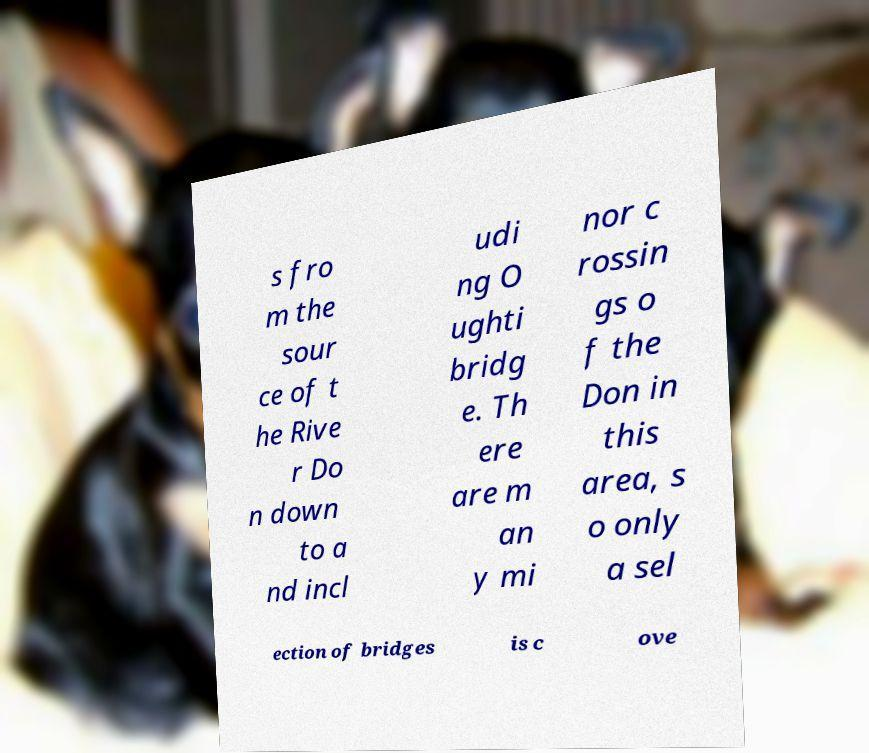There's text embedded in this image that I need extracted. Can you transcribe it verbatim? s fro m the sour ce of t he Rive r Do n down to a nd incl udi ng O ughti bridg e. Th ere are m an y mi nor c rossin gs o f the Don in this area, s o only a sel ection of bridges is c ove 